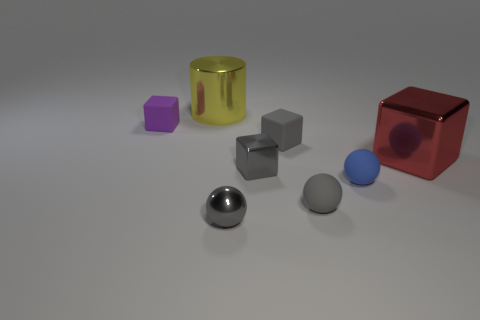Add 1 large brown blocks. How many objects exist? 9 Subtract all cylinders. How many objects are left? 7 Subtract all blocks. Subtract all tiny purple objects. How many objects are left? 3 Add 6 big red things. How many big red things are left? 7 Add 6 big metallic blocks. How many big metallic blocks exist? 7 Subtract 0 brown cubes. How many objects are left? 8 